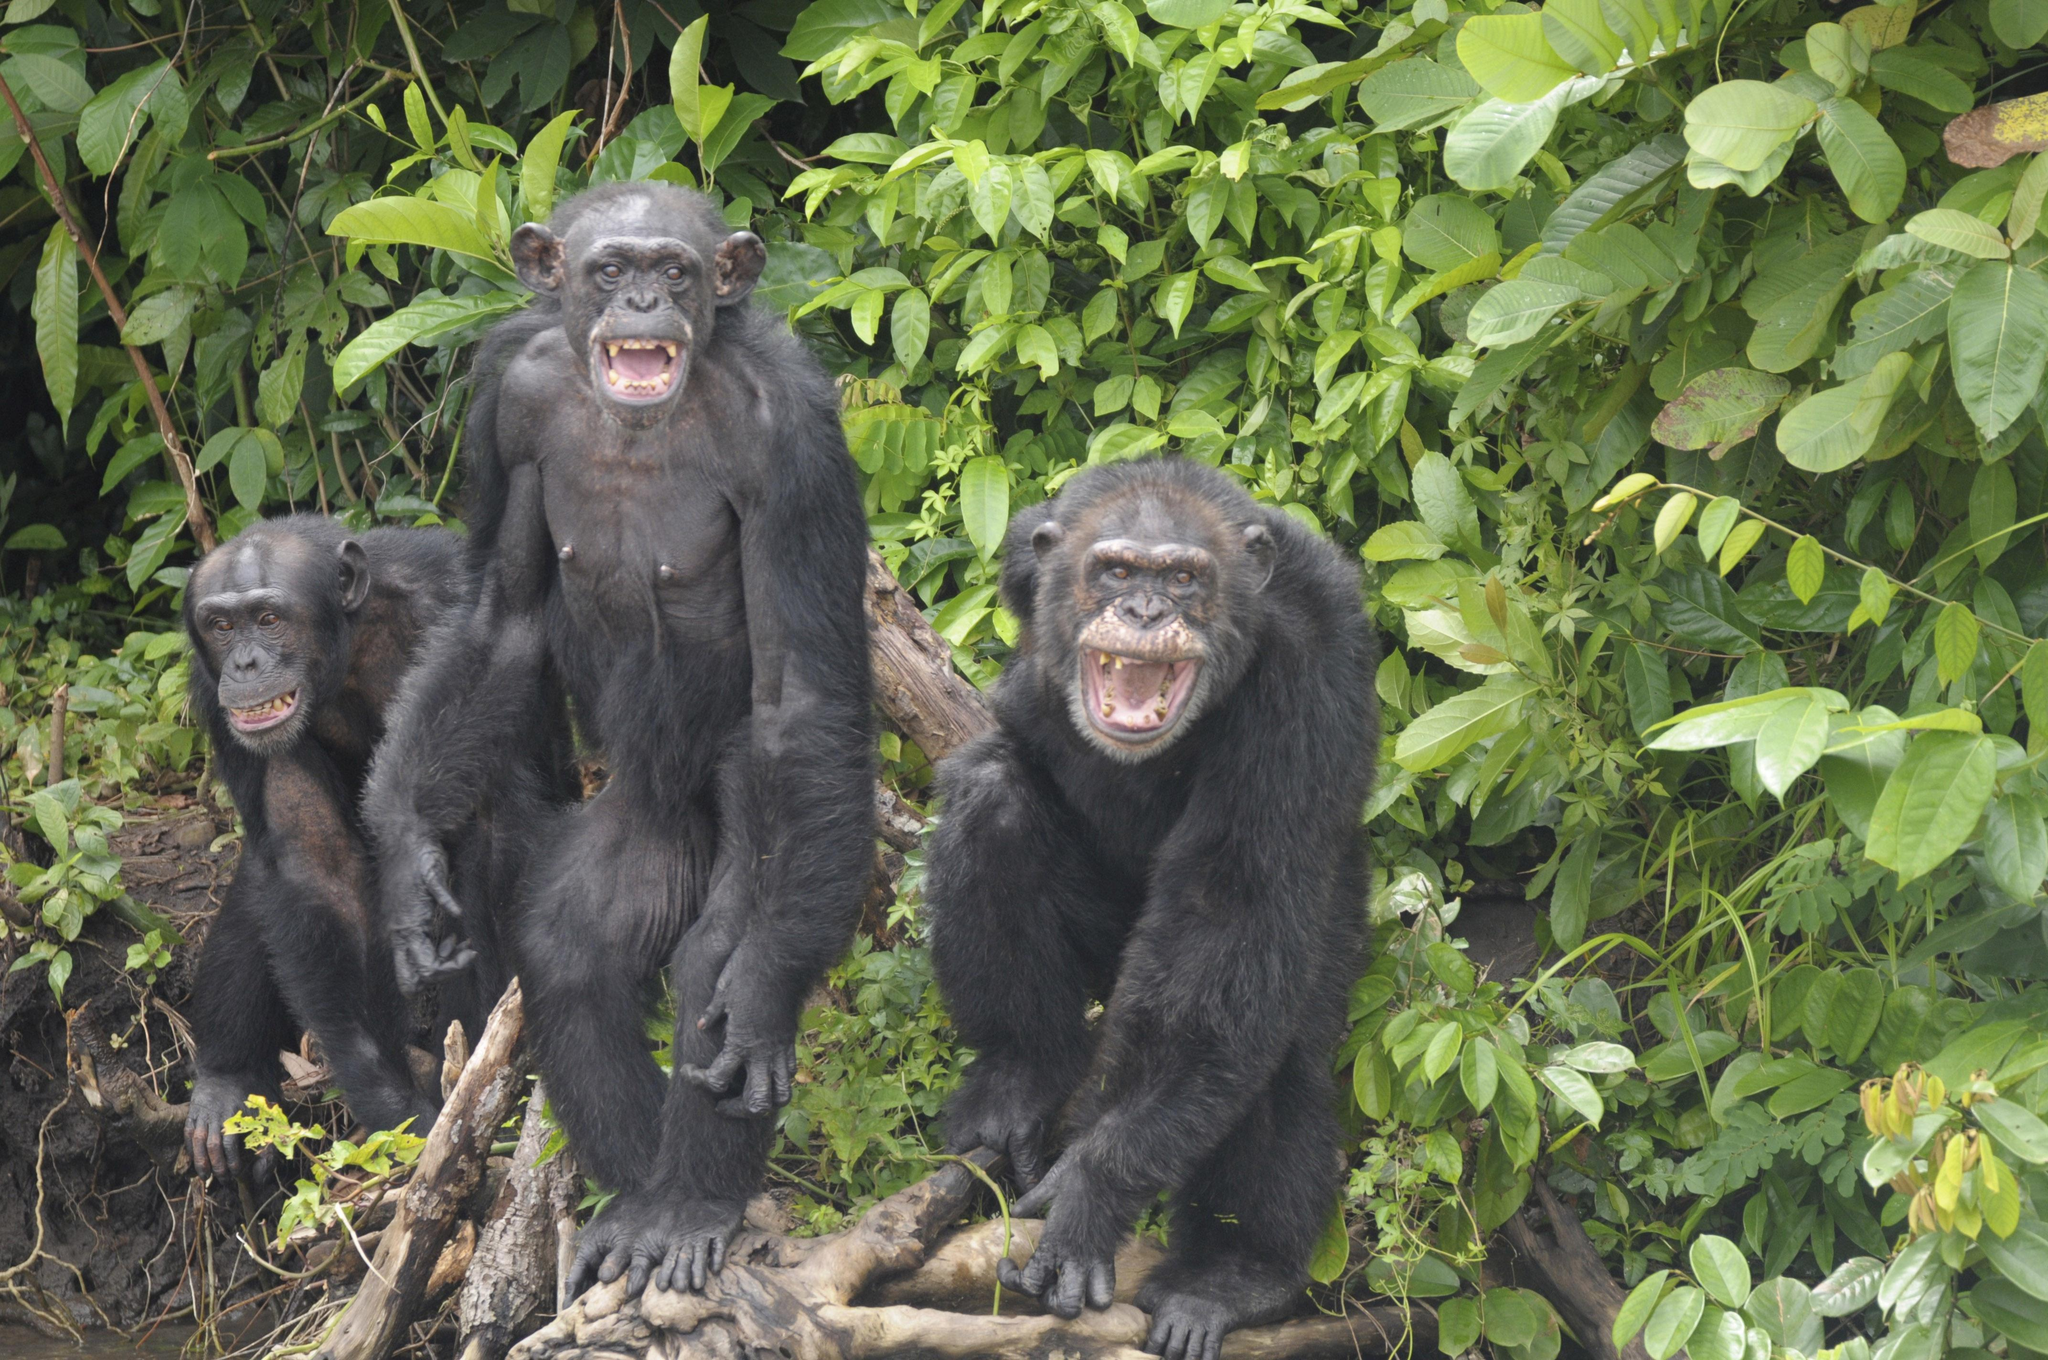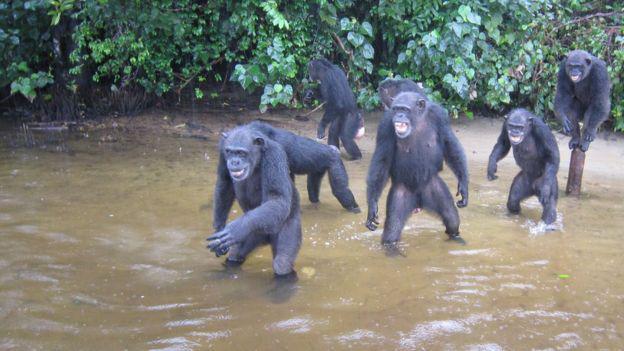The first image is the image on the left, the second image is the image on the right. Assess this claim about the two images: "There is at least four chimpanzees in the right image.". Correct or not? Answer yes or no. Yes. The first image is the image on the left, the second image is the image on the right. Given the left and right images, does the statement "Each image shows one person interacting with at least one chimp, and one image shows a black man with his hand on a chimp's head." hold true? Answer yes or no. No. 